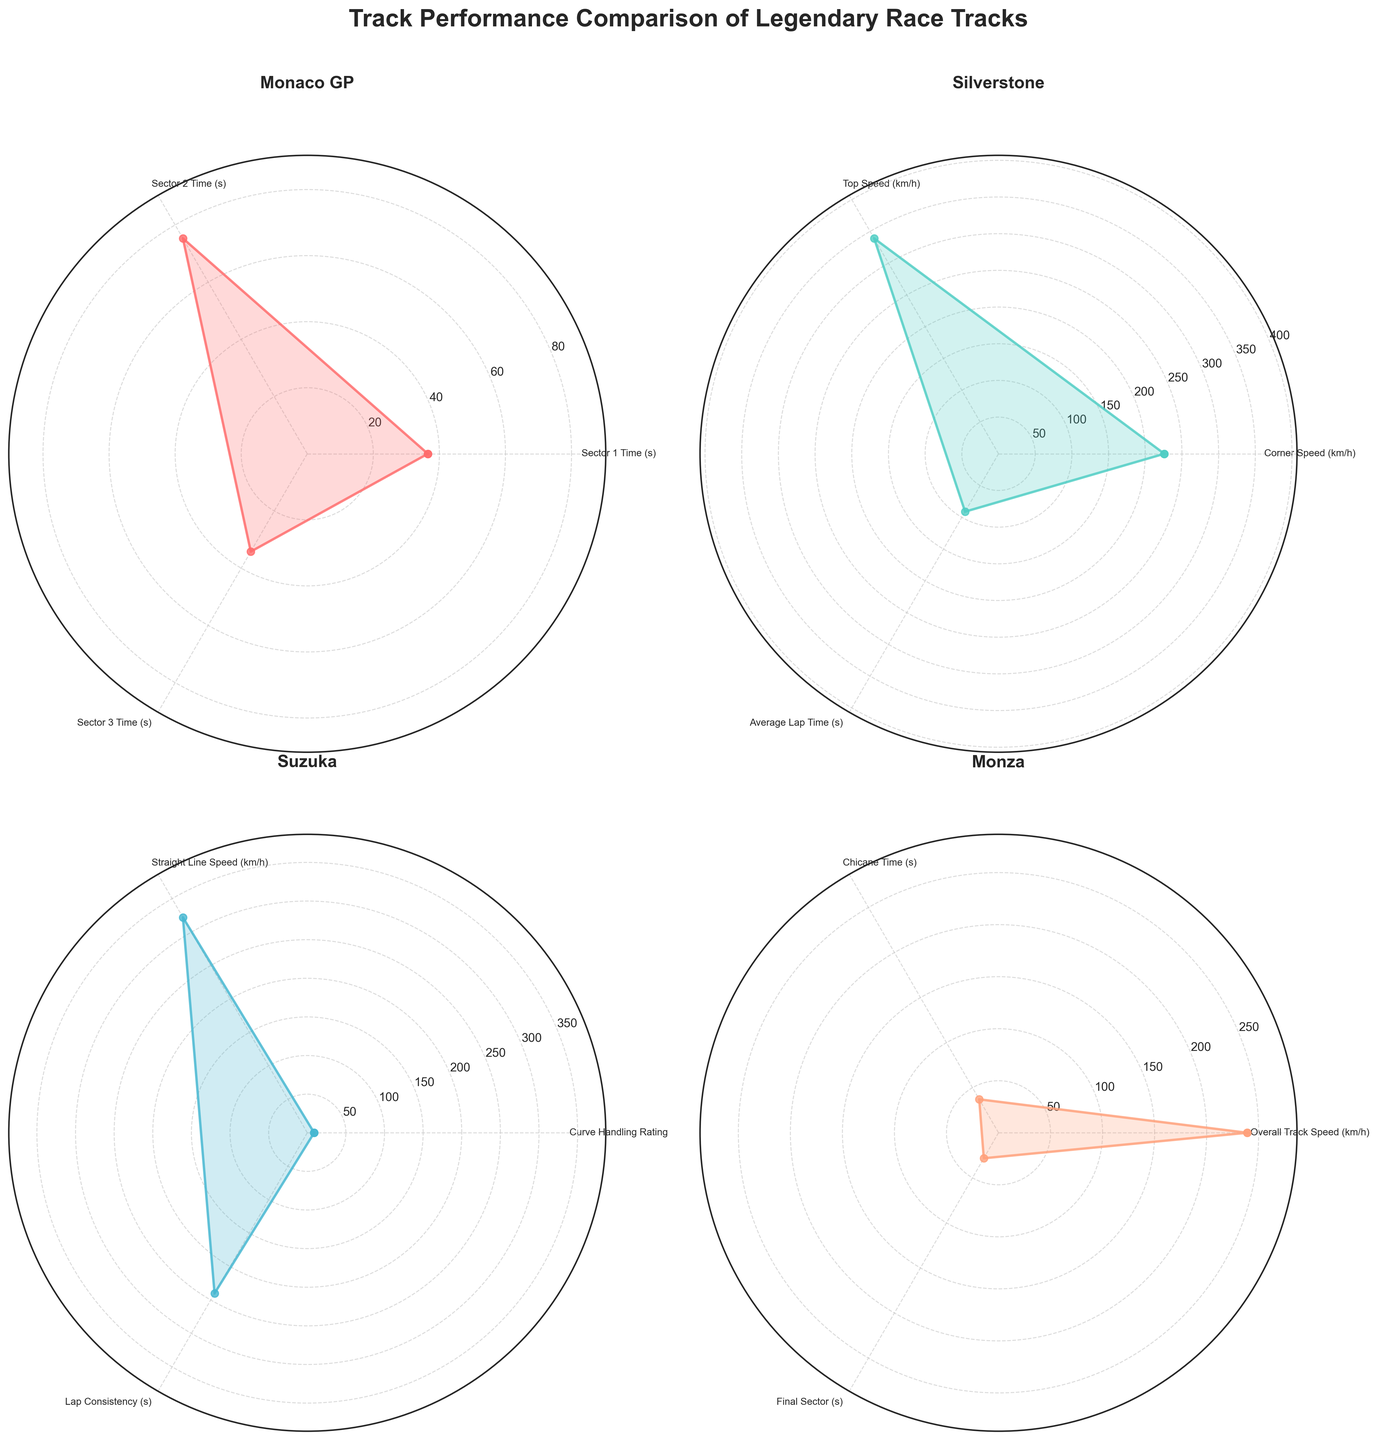What is the title of the figure? The title is placed at the top center of the figure and reads "Track Performance Comparison of Legendary Race Tracks".
Answer: Track Performance Comparison of Legendary Race Tracks How many race tracks are compared in the figure? There are four subplots, each representing a different race track. The tracks are "Monaco GP", "Silverstone", "Suzuka", and "Monza".
Answer: 4 Which race track shows the highest maximum value for any aspect? By examining the maximum values in each subplot's radial axis, "Silverstone" shows the highest maximum value, which is around 340 km/h in Top Speed.
Answer: Silverstone What is the overall track speed for Monza in 2023? The value for "Overall Track Speed (km/h)" in the Monza subplot is closest to 239 km/h.
Answer: 239 km/h What is the Sector 1 Time for Monaco GP in 2023? The value for "Sector 1 Time (s)" in the Monaco GP subplot is closest to 36.5 seconds.
Answer: 36.5 seconds How does the Corner Speed of Silverstone compare to the Curve Handling Rating of Suzuka in 2023? The maximum value for Corner Speed of Silverstone is around 226 km/h, whereas the Curve Handling Rating for Suzuka is about 8.9. Although the metrics differ, we can see that for their respective scales, Suzuka has a slightly higher relative rating.
Answer: Suzuka Curve Handling Rating is relatively higher Which race track has the most consistent values across all aspects? By visually examining each track's range of values, Suzuka appears to have the most consistent values, with all its metrics clustered closely together.
Answer: Suzuka What is the difference between Suzuka’s highest and lowest metrics? Suzuka’s highest value is for "Curve Handling Rating" at around 8.9 and its lowest is for "Lap Consistency" at around 240.1 seconds. The difference is 240.1 - 8.9.
Answer: 231.2 What is the top speed at Silverstone over the past decade as shown in the 2023 data? The value for "Top Speed (km/h)" at Silverstone in 2023 is around 339 km/h.
Answer: 339 km/h How much has the Final Sector time at Monza improved compared to the previous year (2022)? The Final Sector time at Monza in 2023 is approximately 28.3 seconds, and in 2022 it was around 28.2 seconds. The difference is 28.3 - 28.2 = 0.1 seconds.
Answer: 0.1 seconds 